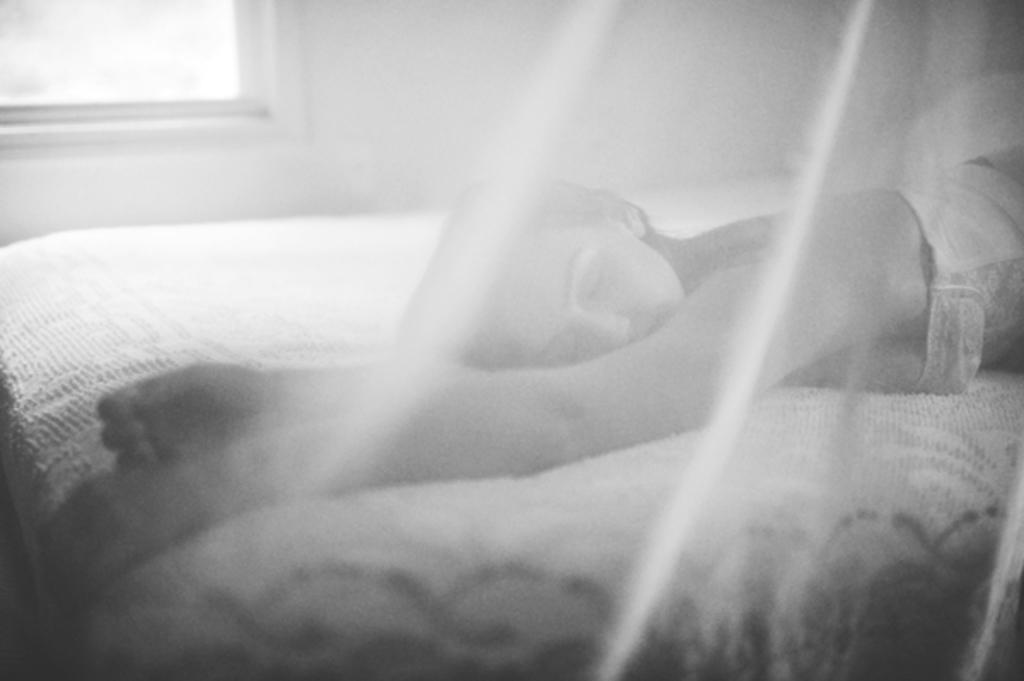What is the woman doing in the image? The woman is lying on the bed in the image. What can be seen outside the room in the image? There is a window in the image, which suggests that there is a view of the outside. What is one of the main architectural features in the image? There is a wall in the image. What type of fowl can be seen in the image? There is no fowl present in the image. Is there a source of water visible in the image? There is no source of water visible in the image. 